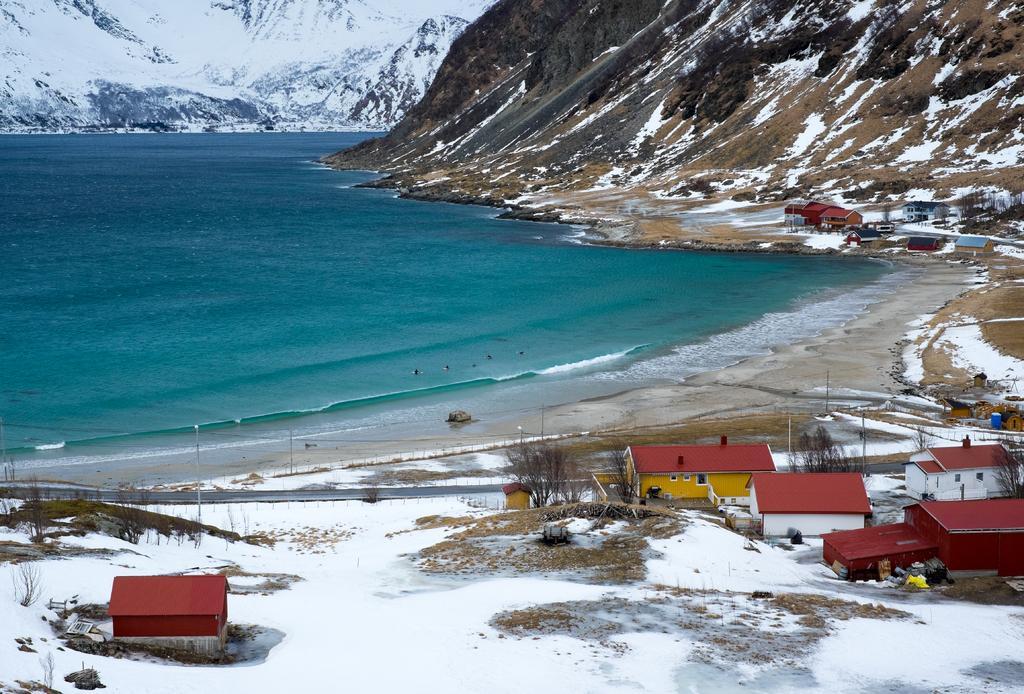Could you give a brief overview of what you see in this image? In this image there are houses and the land is covered with snow, there is a seashore, in the background there are mountains and a sea. 